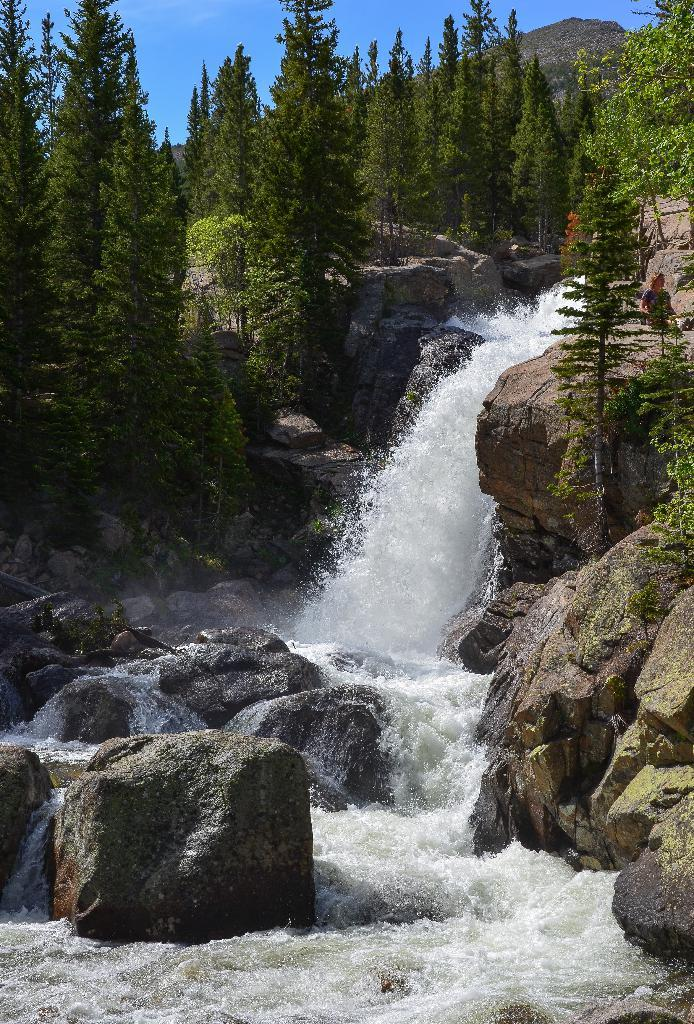What can be seen in the sky in the image? The sky is visible in the image. What type of natural features are present in the image? There are rocks, trees, and a waterfall in the image. Can you describe the person in the image? There is a person on the right side of the image. What type of memory is being stored in the rocks in the image? There is no indication in the image that the rocks are storing any memories. 